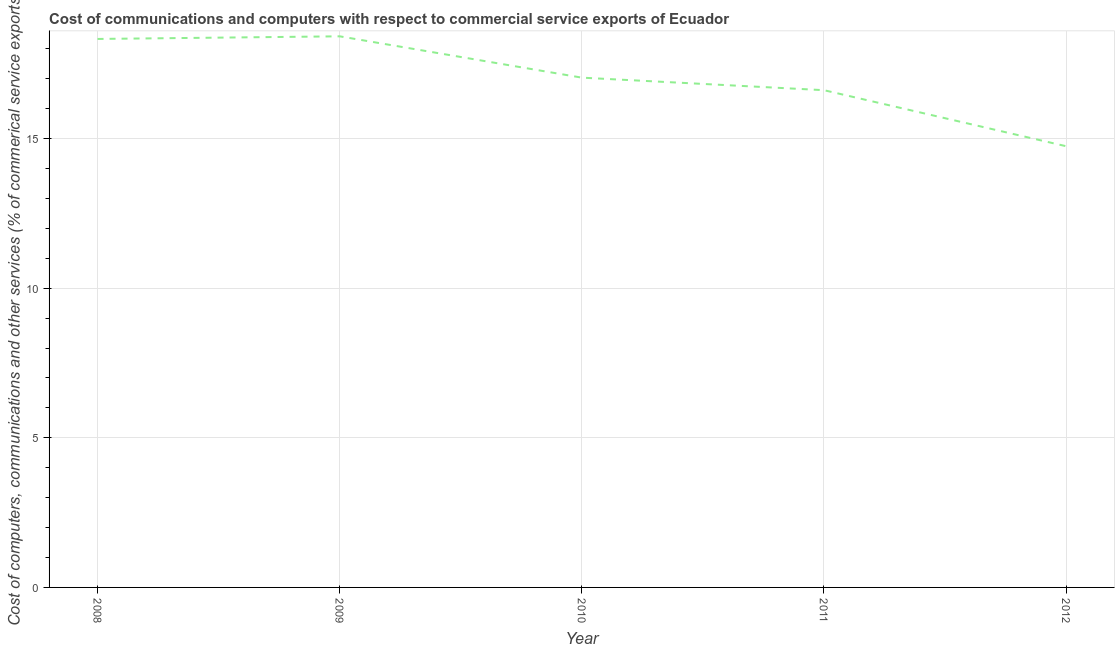What is the cost of communications in 2012?
Your answer should be compact. 14.74. Across all years, what is the maximum  computer and other services?
Offer a terse response. 18.42. Across all years, what is the minimum cost of communications?
Your answer should be very brief. 14.74. In which year was the cost of communications minimum?
Your answer should be very brief. 2012. What is the sum of the cost of communications?
Make the answer very short. 85.14. What is the difference between the  computer and other services in 2010 and 2012?
Your answer should be very brief. 2.29. What is the average  computer and other services per year?
Give a very brief answer. 17.03. What is the median cost of communications?
Your response must be concise. 17.04. Do a majority of the years between 2009 and 2010 (inclusive) have  computer and other services greater than 12 %?
Provide a short and direct response. Yes. What is the ratio of the  computer and other services in 2009 to that in 2011?
Make the answer very short. 1.11. Is the difference between the cost of communications in 2008 and 2012 greater than the difference between any two years?
Offer a very short reply. No. What is the difference between the highest and the second highest cost of communications?
Your response must be concise. 0.09. Is the sum of the cost of communications in 2010 and 2011 greater than the maximum cost of communications across all years?
Give a very brief answer. Yes. What is the difference between the highest and the lowest cost of communications?
Your answer should be very brief. 3.67. In how many years, is the  computer and other services greater than the average  computer and other services taken over all years?
Provide a short and direct response. 3. Does the cost of communications monotonically increase over the years?
Your response must be concise. No. How many years are there in the graph?
Your answer should be compact. 5. What is the difference between two consecutive major ticks on the Y-axis?
Ensure brevity in your answer.  5. Does the graph contain grids?
Ensure brevity in your answer.  Yes. What is the title of the graph?
Offer a very short reply. Cost of communications and computers with respect to commercial service exports of Ecuador. What is the label or title of the Y-axis?
Make the answer very short. Cost of computers, communications and other services (% of commerical service exports). What is the Cost of computers, communications and other services (% of commerical service exports) of 2008?
Make the answer very short. 18.33. What is the Cost of computers, communications and other services (% of commerical service exports) in 2009?
Keep it short and to the point. 18.42. What is the Cost of computers, communications and other services (% of commerical service exports) of 2010?
Provide a succinct answer. 17.04. What is the Cost of computers, communications and other services (% of commerical service exports) in 2011?
Your answer should be very brief. 16.62. What is the Cost of computers, communications and other services (% of commerical service exports) in 2012?
Give a very brief answer. 14.74. What is the difference between the Cost of computers, communications and other services (% of commerical service exports) in 2008 and 2009?
Ensure brevity in your answer.  -0.09. What is the difference between the Cost of computers, communications and other services (% of commerical service exports) in 2008 and 2010?
Provide a short and direct response. 1.29. What is the difference between the Cost of computers, communications and other services (% of commerical service exports) in 2008 and 2011?
Give a very brief answer. 1.71. What is the difference between the Cost of computers, communications and other services (% of commerical service exports) in 2008 and 2012?
Your response must be concise. 3.58. What is the difference between the Cost of computers, communications and other services (% of commerical service exports) in 2009 and 2010?
Keep it short and to the point. 1.38. What is the difference between the Cost of computers, communications and other services (% of commerical service exports) in 2009 and 2011?
Ensure brevity in your answer.  1.8. What is the difference between the Cost of computers, communications and other services (% of commerical service exports) in 2009 and 2012?
Provide a short and direct response. 3.67. What is the difference between the Cost of computers, communications and other services (% of commerical service exports) in 2010 and 2011?
Ensure brevity in your answer.  0.42. What is the difference between the Cost of computers, communications and other services (% of commerical service exports) in 2010 and 2012?
Offer a very short reply. 2.29. What is the difference between the Cost of computers, communications and other services (% of commerical service exports) in 2011 and 2012?
Keep it short and to the point. 1.87. What is the ratio of the Cost of computers, communications and other services (% of commerical service exports) in 2008 to that in 2009?
Your answer should be very brief. 0.99. What is the ratio of the Cost of computers, communications and other services (% of commerical service exports) in 2008 to that in 2010?
Offer a terse response. 1.08. What is the ratio of the Cost of computers, communications and other services (% of commerical service exports) in 2008 to that in 2011?
Provide a succinct answer. 1.1. What is the ratio of the Cost of computers, communications and other services (% of commerical service exports) in 2008 to that in 2012?
Provide a succinct answer. 1.24. What is the ratio of the Cost of computers, communications and other services (% of commerical service exports) in 2009 to that in 2010?
Make the answer very short. 1.08. What is the ratio of the Cost of computers, communications and other services (% of commerical service exports) in 2009 to that in 2011?
Ensure brevity in your answer.  1.11. What is the ratio of the Cost of computers, communications and other services (% of commerical service exports) in 2009 to that in 2012?
Give a very brief answer. 1.25. What is the ratio of the Cost of computers, communications and other services (% of commerical service exports) in 2010 to that in 2012?
Make the answer very short. 1.16. What is the ratio of the Cost of computers, communications and other services (% of commerical service exports) in 2011 to that in 2012?
Give a very brief answer. 1.13. 